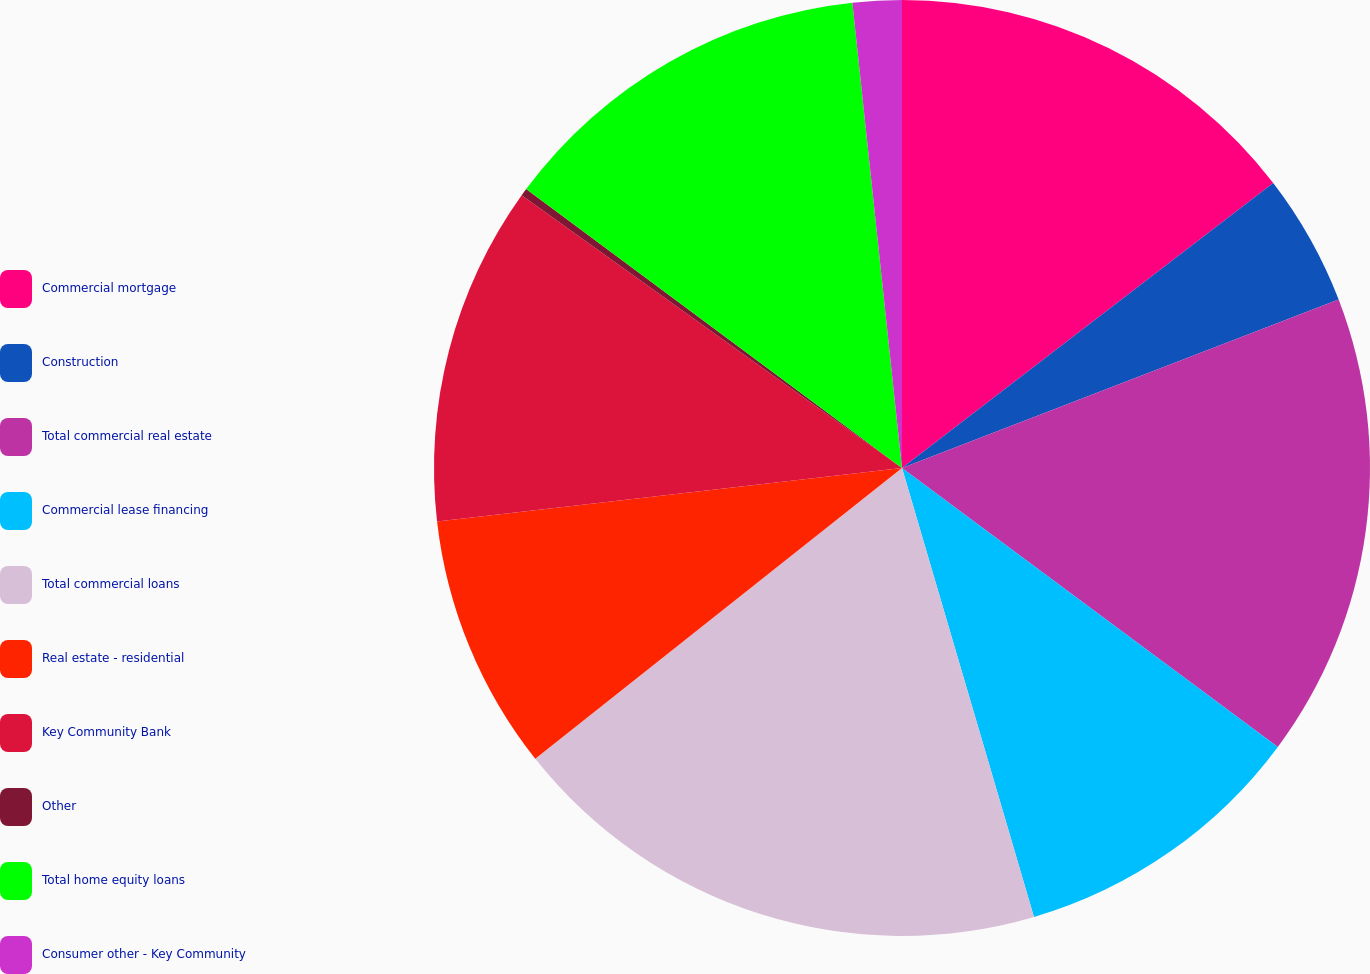Convert chart. <chart><loc_0><loc_0><loc_500><loc_500><pie_chart><fcel>Commercial mortgage<fcel>Construction<fcel>Total commercial real estate<fcel>Commercial lease financing<fcel>Total commercial loans<fcel>Real estate - residential<fcel>Key Community Bank<fcel>Other<fcel>Total home equity loans<fcel>Consumer other - Key Community<nl><fcel>14.58%<fcel>4.56%<fcel>16.02%<fcel>10.29%<fcel>18.88%<fcel>8.85%<fcel>11.72%<fcel>0.26%<fcel>13.15%<fcel>1.69%<nl></chart> 